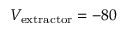<formula> <loc_0><loc_0><loc_500><loc_500>V _ { e x t r a c t o r } = - 8 0</formula> 